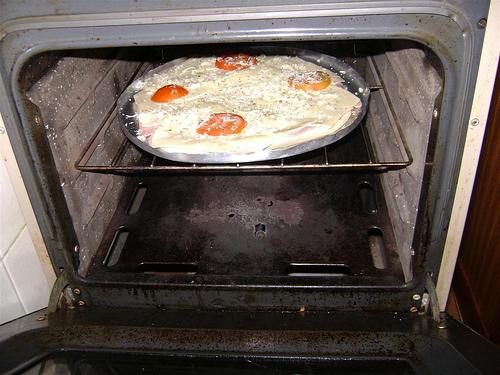When was the oven made?
Quick response, please. 1980. How many racks are in the oven?
Write a very short answer. 1. Does the oven appear to be on or off?
Answer briefly. Off. Is the pizza done?
Answer briefly. No. How many tomato slices?
Keep it brief. 4. Is this a lasagna in the oven?
Answer briefly. No. 